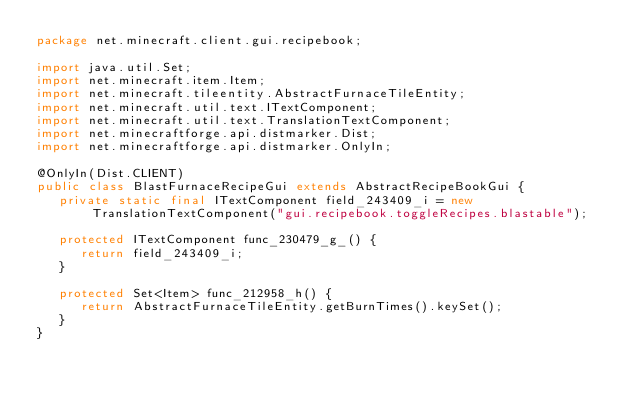Convert code to text. <code><loc_0><loc_0><loc_500><loc_500><_Java_>package net.minecraft.client.gui.recipebook;

import java.util.Set;
import net.minecraft.item.Item;
import net.minecraft.tileentity.AbstractFurnaceTileEntity;
import net.minecraft.util.text.ITextComponent;
import net.minecraft.util.text.TranslationTextComponent;
import net.minecraftforge.api.distmarker.Dist;
import net.minecraftforge.api.distmarker.OnlyIn;

@OnlyIn(Dist.CLIENT)
public class BlastFurnaceRecipeGui extends AbstractRecipeBookGui {
   private static final ITextComponent field_243409_i = new TranslationTextComponent("gui.recipebook.toggleRecipes.blastable");

   protected ITextComponent func_230479_g_() {
      return field_243409_i;
   }

   protected Set<Item> func_212958_h() {
      return AbstractFurnaceTileEntity.getBurnTimes().keySet();
   }
}
</code> 